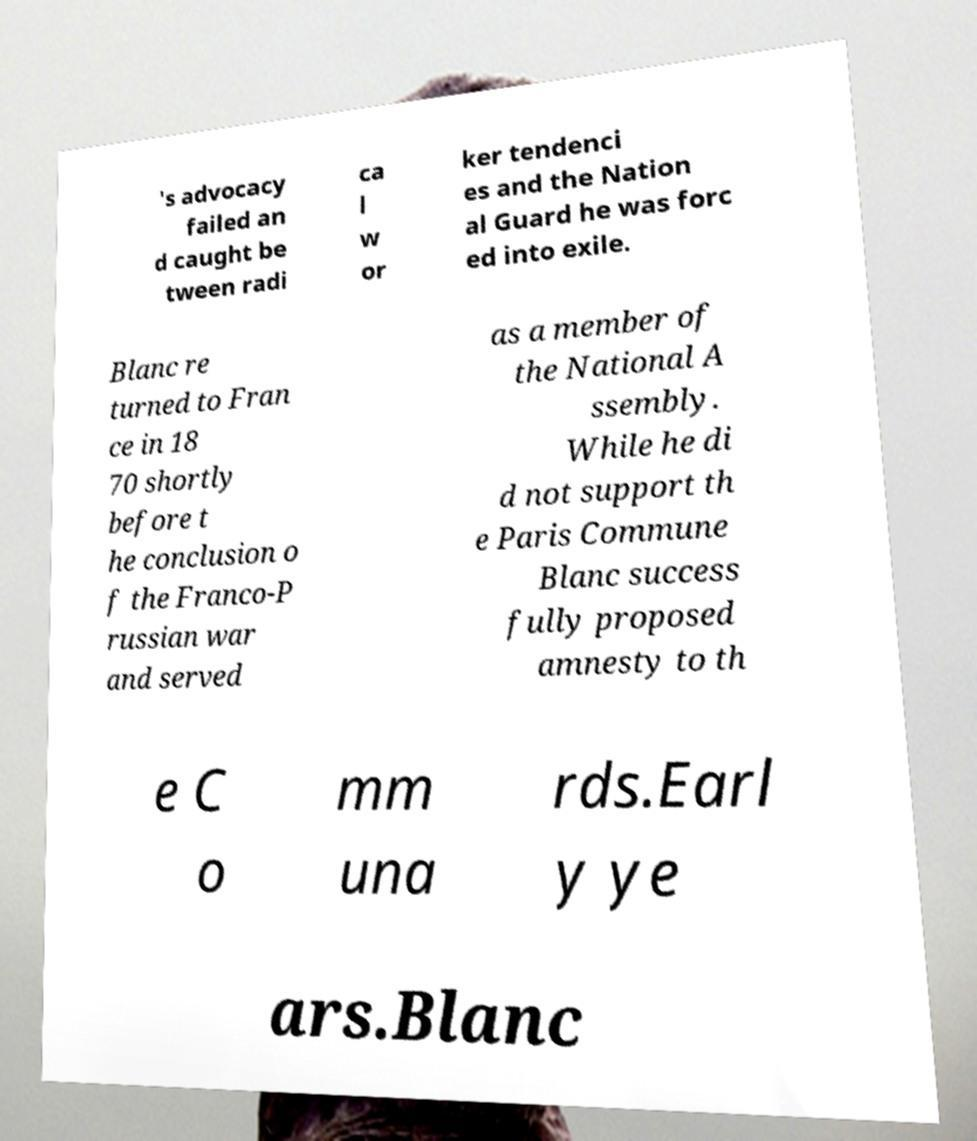There's text embedded in this image that I need extracted. Can you transcribe it verbatim? 's advocacy failed an d caught be tween radi ca l w or ker tendenci es and the Nation al Guard he was forc ed into exile. Blanc re turned to Fran ce in 18 70 shortly before t he conclusion o f the Franco-P russian war and served as a member of the National A ssembly. While he di d not support th e Paris Commune Blanc success fully proposed amnesty to th e C o mm una rds.Earl y ye ars.Blanc 